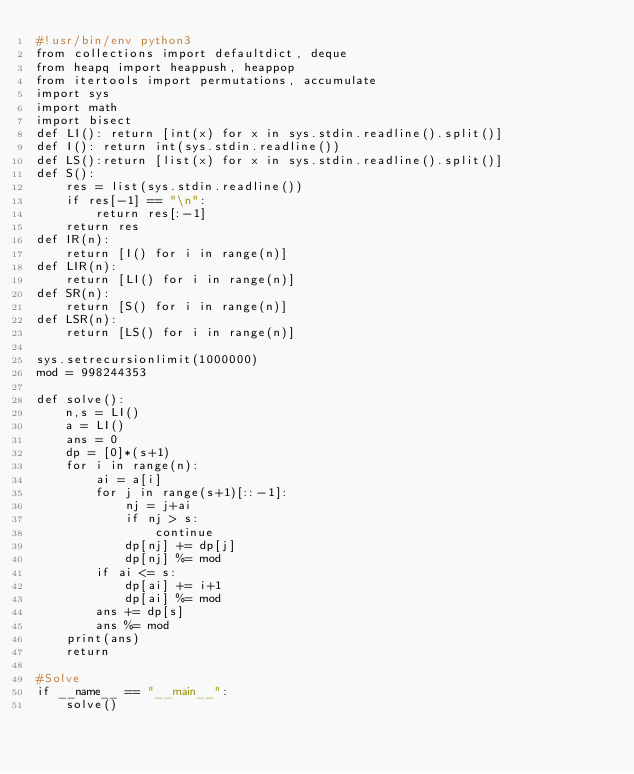Convert code to text. <code><loc_0><loc_0><loc_500><loc_500><_Python_>#!usr/bin/env python3
from collections import defaultdict, deque
from heapq import heappush, heappop
from itertools import permutations, accumulate
import sys
import math
import bisect
def LI(): return [int(x) for x in sys.stdin.readline().split()]
def I(): return int(sys.stdin.readline())
def LS():return [list(x) for x in sys.stdin.readline().split()]
def S():
    res = list(sys.stdin.readline())
    if res[-1] == "\n":
        return res[:-1]
    return res
def IR(n):
    return [I() for i in range(n)]
def LIR(n):
    return [LI() for i in range(n)]
def SR(n):
    return [S() for i in range(n)]
def LSR(n):
    return [LS() for i in range(n)]

sys.setrecursionlimit(1000000)
mod = 998244353

def solve():
    n,s = LI()
    a = LI()
    ans = 0
    dp = [0]*(s+1)
    for i in range(n):
        ai = a[i]
        for j in range(s+1)[::-1]:
            nj = j+ai
            if nj > s:
                continue
            dp[nj] += dp[j]
            dp[nj] %= mod
        if ai <= s:
            dp[ai] += i+1
            dp[ai] %= mod
        ans += dp[s]
        ans %= mod
    print(ans)
    return

#Solve
if __name__ == "__main__":
    solve()
</code> 